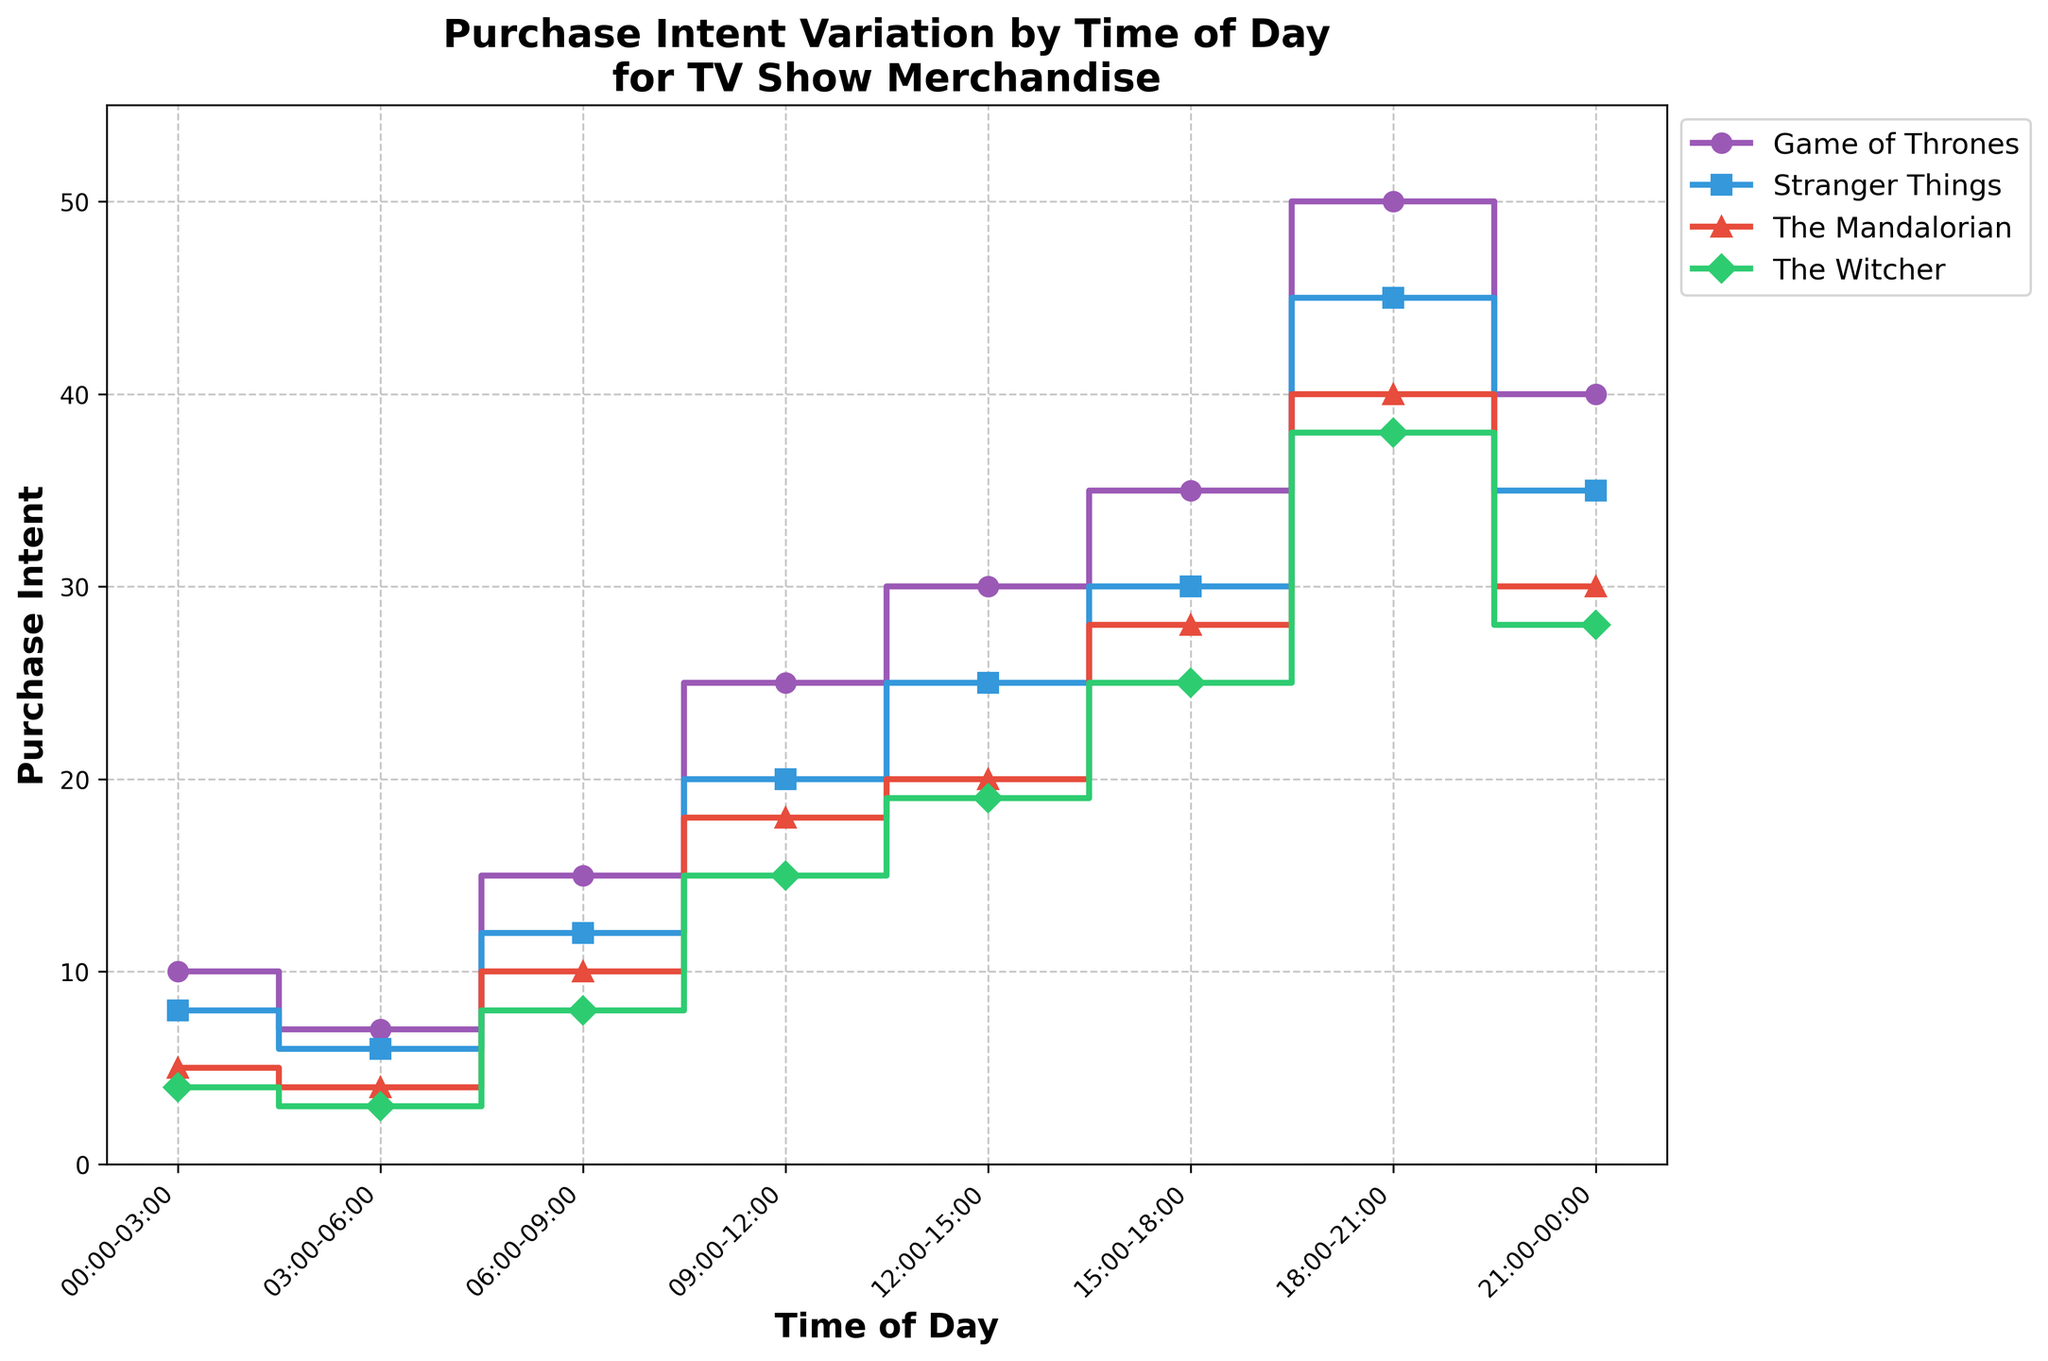What's the title of the figure? The information is located at the top of the figure.
Answer: Purchase Intent Variation by Time of Day for TV Show Merchandise What time of the day has the highest purchase intent for Game of Thrones merchandise? By looking at the highest point in the Game of Thrones merchandise line.
Answer: 18:00-21:00 Which merchandise has the lowest purchase intent from 00:00-03:00? By comparing the values of all merchandise during 00:00-03:00.
Answer: The Witcher What's the difference in purchase intent for Stranger Things merchandise between 06:00-09:00 and 09:00-12:00? Subtract the purchase intent for 06:00-09:00 from that of 09:00-12:00 for Stranger Things merchandise.
Answer: 8 During which time period is the purchase intent for The Mandalorian merchandise equal to that of Game of Thrones merchandise from 03:00-06:00? Compare The Mandalorian's purchase intent across all time periods to Game of Thrones merchandise's value of 7 from 03:00-06:00.
Answer: 00:00-03:00 What's the average purchase intent for The Witcher merchandise throughout the day? Sum all purchase intent values for The Witcher merchandise and divide by the number of time periods. (4+3+8+15+19+25+38+28)/8 = 140/8
Answer: 17.5 How does the purchase intent for The Mandalorian from 15:00-18:00 compare to Game of Thrones merchandise from 21:00-00:00? Compare the values directly in the respective time slots.
Answer: The Mandalorian is higher Which merchandise shows almost a linear increase in purchase intent throughout the day? Look for merchandise with a relatively consistent increase in purchase intent across time periods.
Answer: Game of Thrones From 18:00-21:00 to 21:00-00:00, which merchandise shows a decrease in purchase intent? Identify which merchandise lines show a drop in value from 18:00-21:00 to 21:00-00:00.
Answer: All except The Witcher What is the total purchase intent for Stranger Things and The Witcher merchandise combined at 09:00-12:00? Add the purchase intents for Stranger Things and The Witcher at 09:00-12:00. 20 (Stranger Things) + 15 (The Witcher) = 35
Answer: 35 